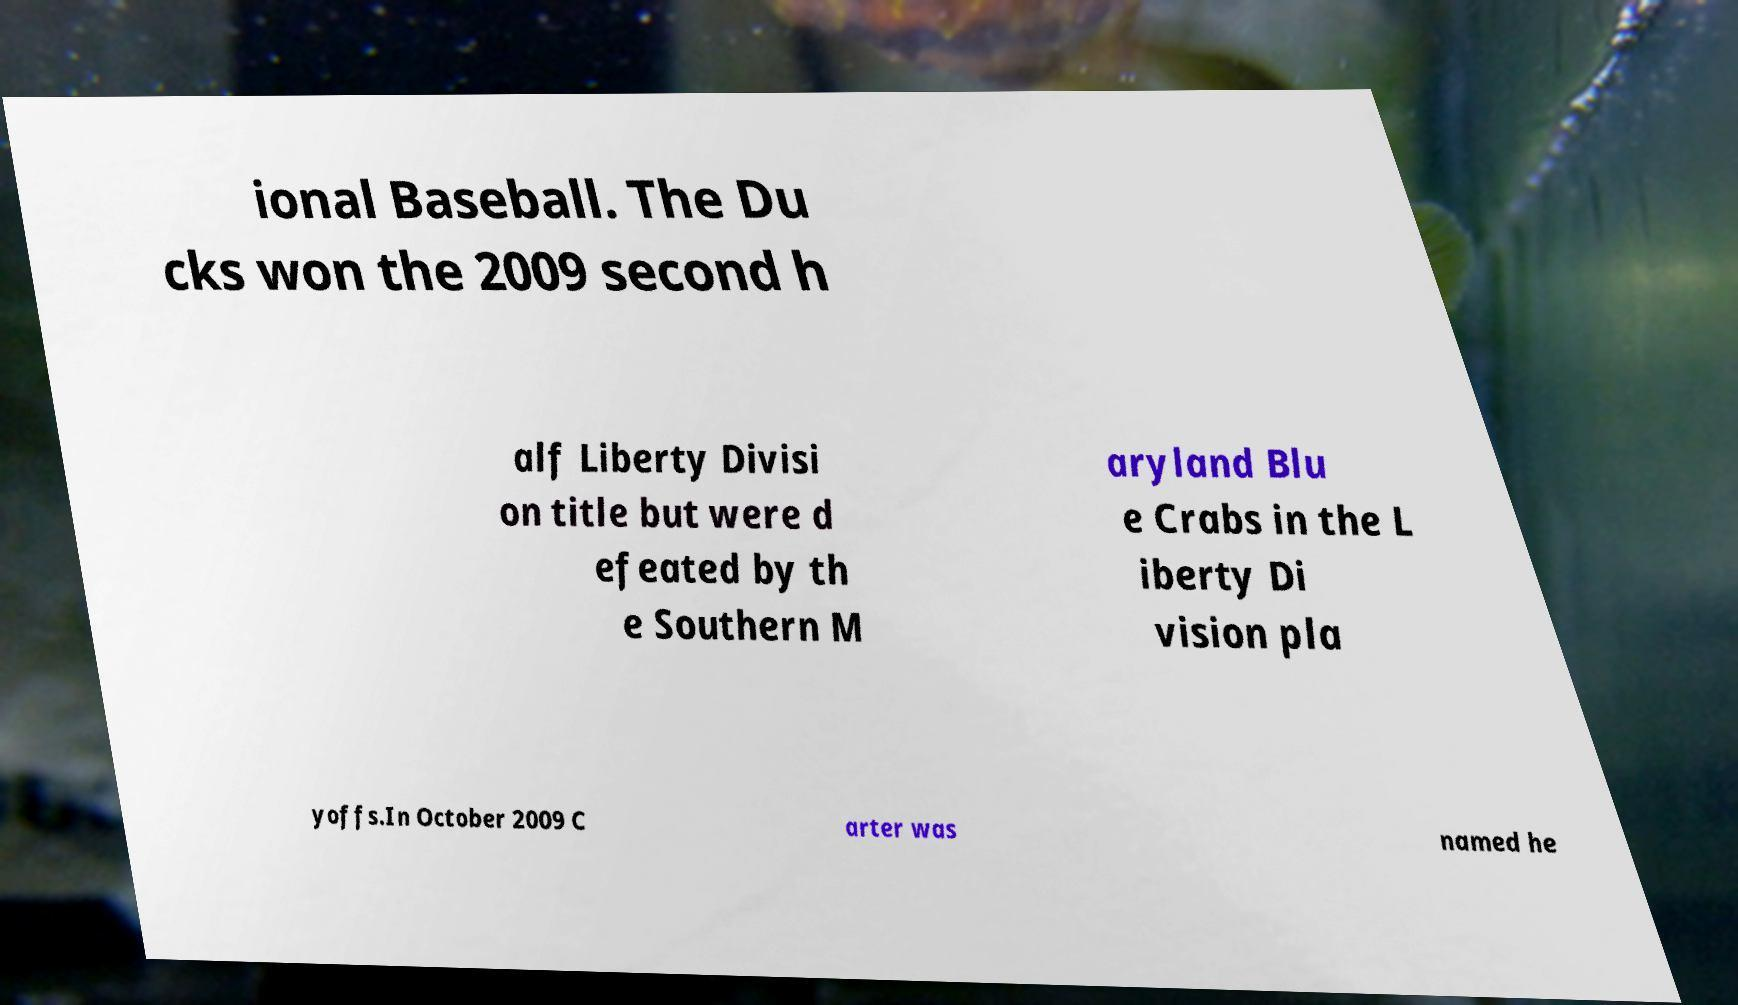I need the written content from this picture converted into text. Can you do that? ional Baseball. The Du cks won the 2009 second h alf Liberty Divisi on title but were d efeated by th e Southern M aryland Blu e Crabs in the L iberty Di vision pla yoffs.In October 2009 C arter was named he 